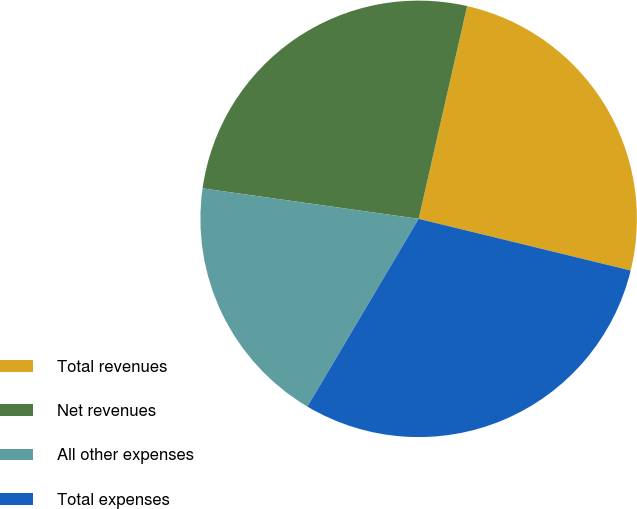<chart> <loc_0><loc_0><loc_500><loc_500><pie_chart><fcel>Total revenues<fcel>Net revenues<fcel>All other expenses<fcel>Total expenses<nl><fcel>25.24%<fcel>26.34%<fcel>18.72%<fcel>29.71%<nl></chart> 